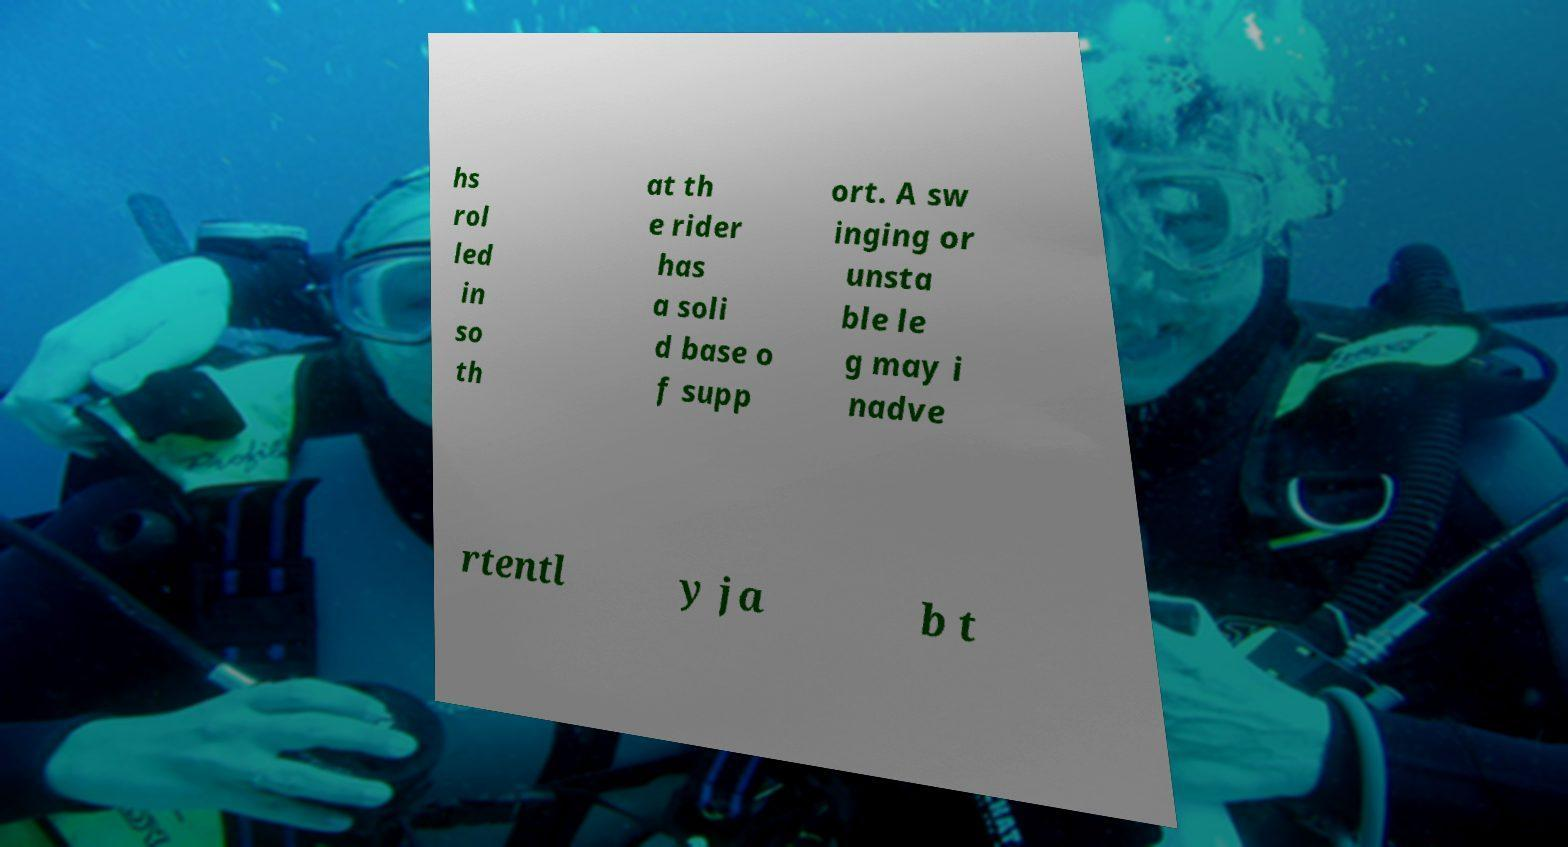Please read and relay the text visible in this image. What does it say? hs rol led in so th at th e rider has a soli d base o f supp ort. A sw inging or unsta ble le g may i nadve rtentl y ja b t 